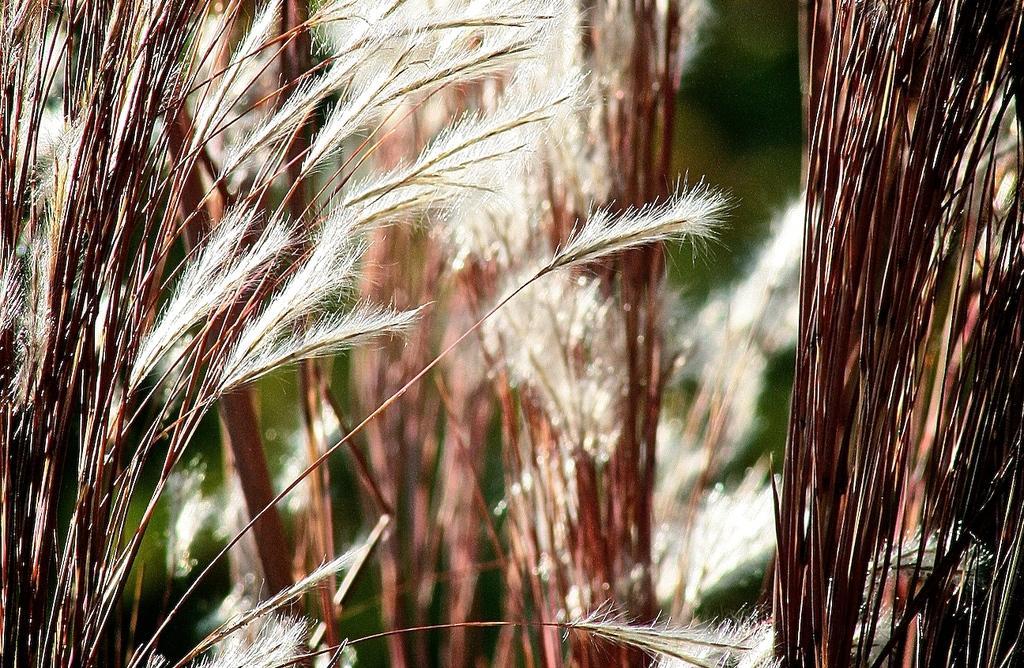Can you describe this image briefly? In this image we can see a group of plants. 